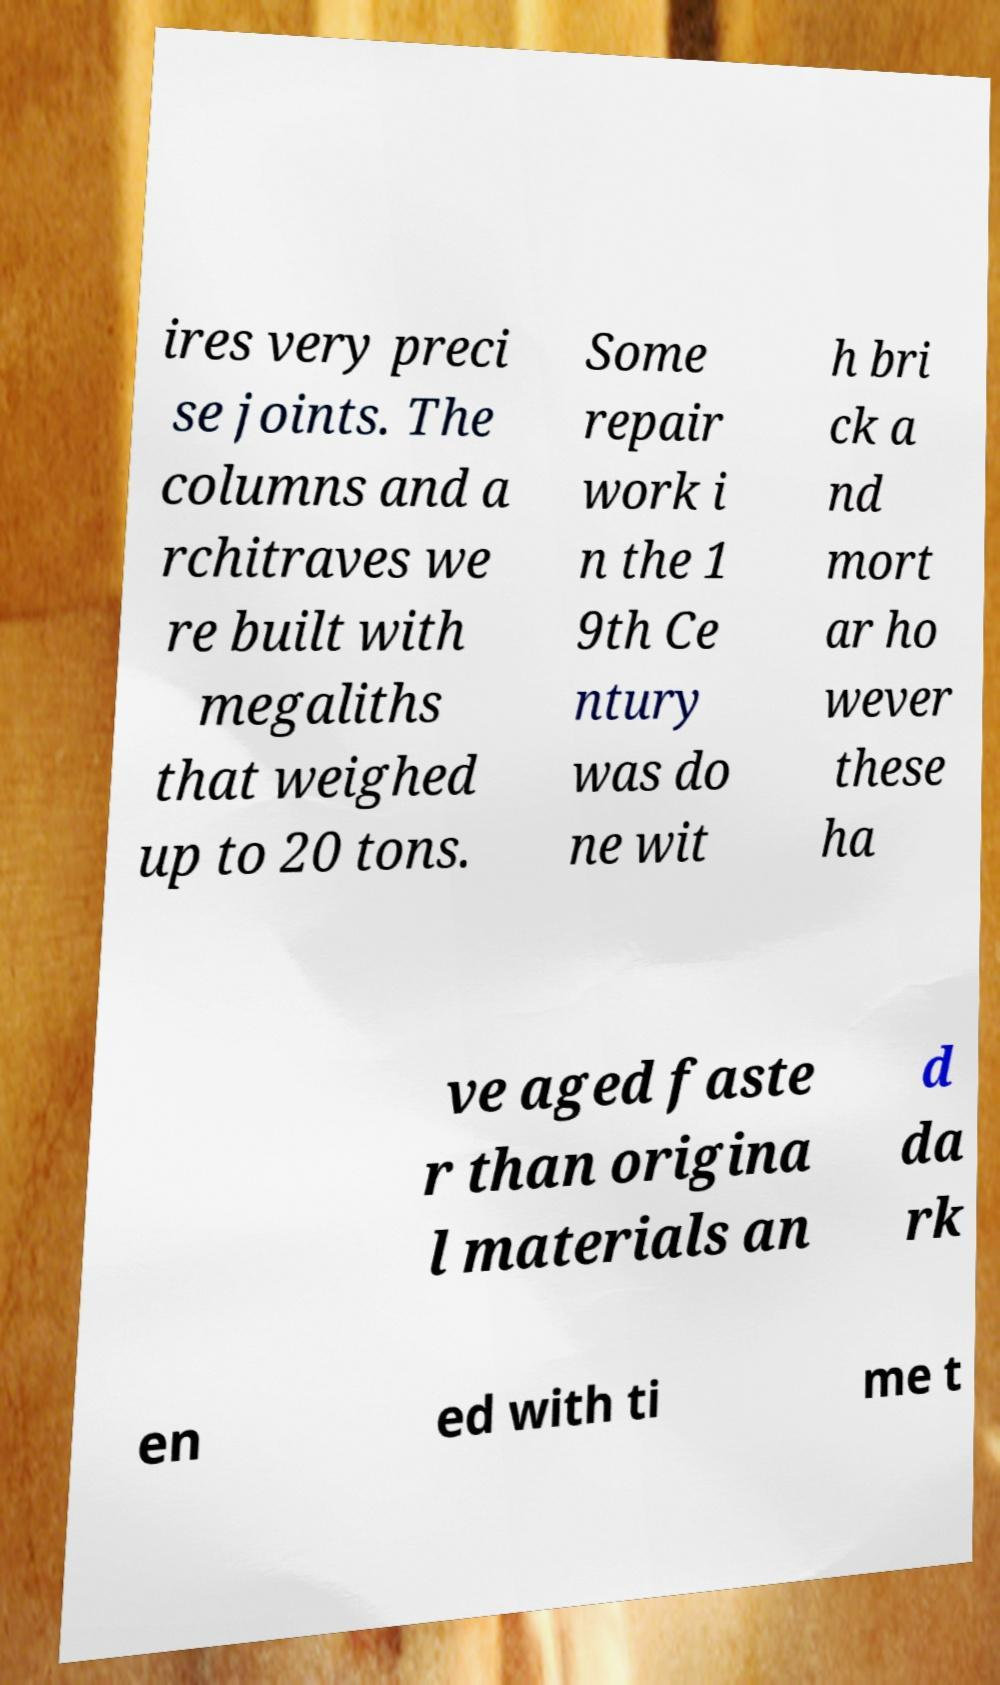Can you read and provide the text displayed in the image?This photo seems to have some interesting text. Can you extract and type it out for me? ires very preci se joints. The columns and a rchitraves we re built with megaliths that weighed up to 20 tons. Some repair work i n the 1 9th Ce ntury was do ne wit h bri ck a nd mort ar ho wever these ha ve aged faste r than origina l materials an d da rk en ed with ti me t 